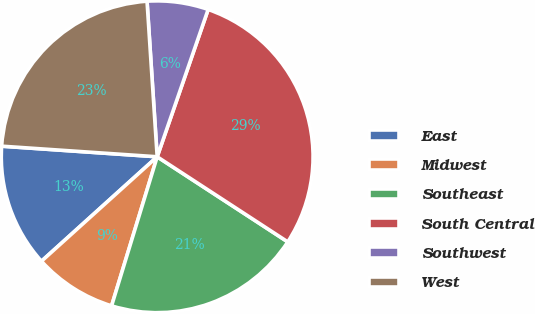Convert chart. <chart><loc_0><loc_0><loc_500><loc_500><pie_chart><fcel>East<fcel>Midwest<fcel>Southeast<fcel>South Central<fcel>Southwest<fcel>West<nl><fcel>12.77%<fcel>8.59%<fcel>20.53%<fcel>28.89%<fcel>6.34%<fcel>22.88%<nl></chart> 